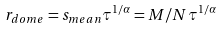Convert formula to latex. <formula><loc_0><loc_0><loc_500><loc_500>r _ { d o m e } = s _ { m e a n } \tau ^ { 1 / \alpha } = M / N \tau ^ { 1 / \alpha }</formula> 